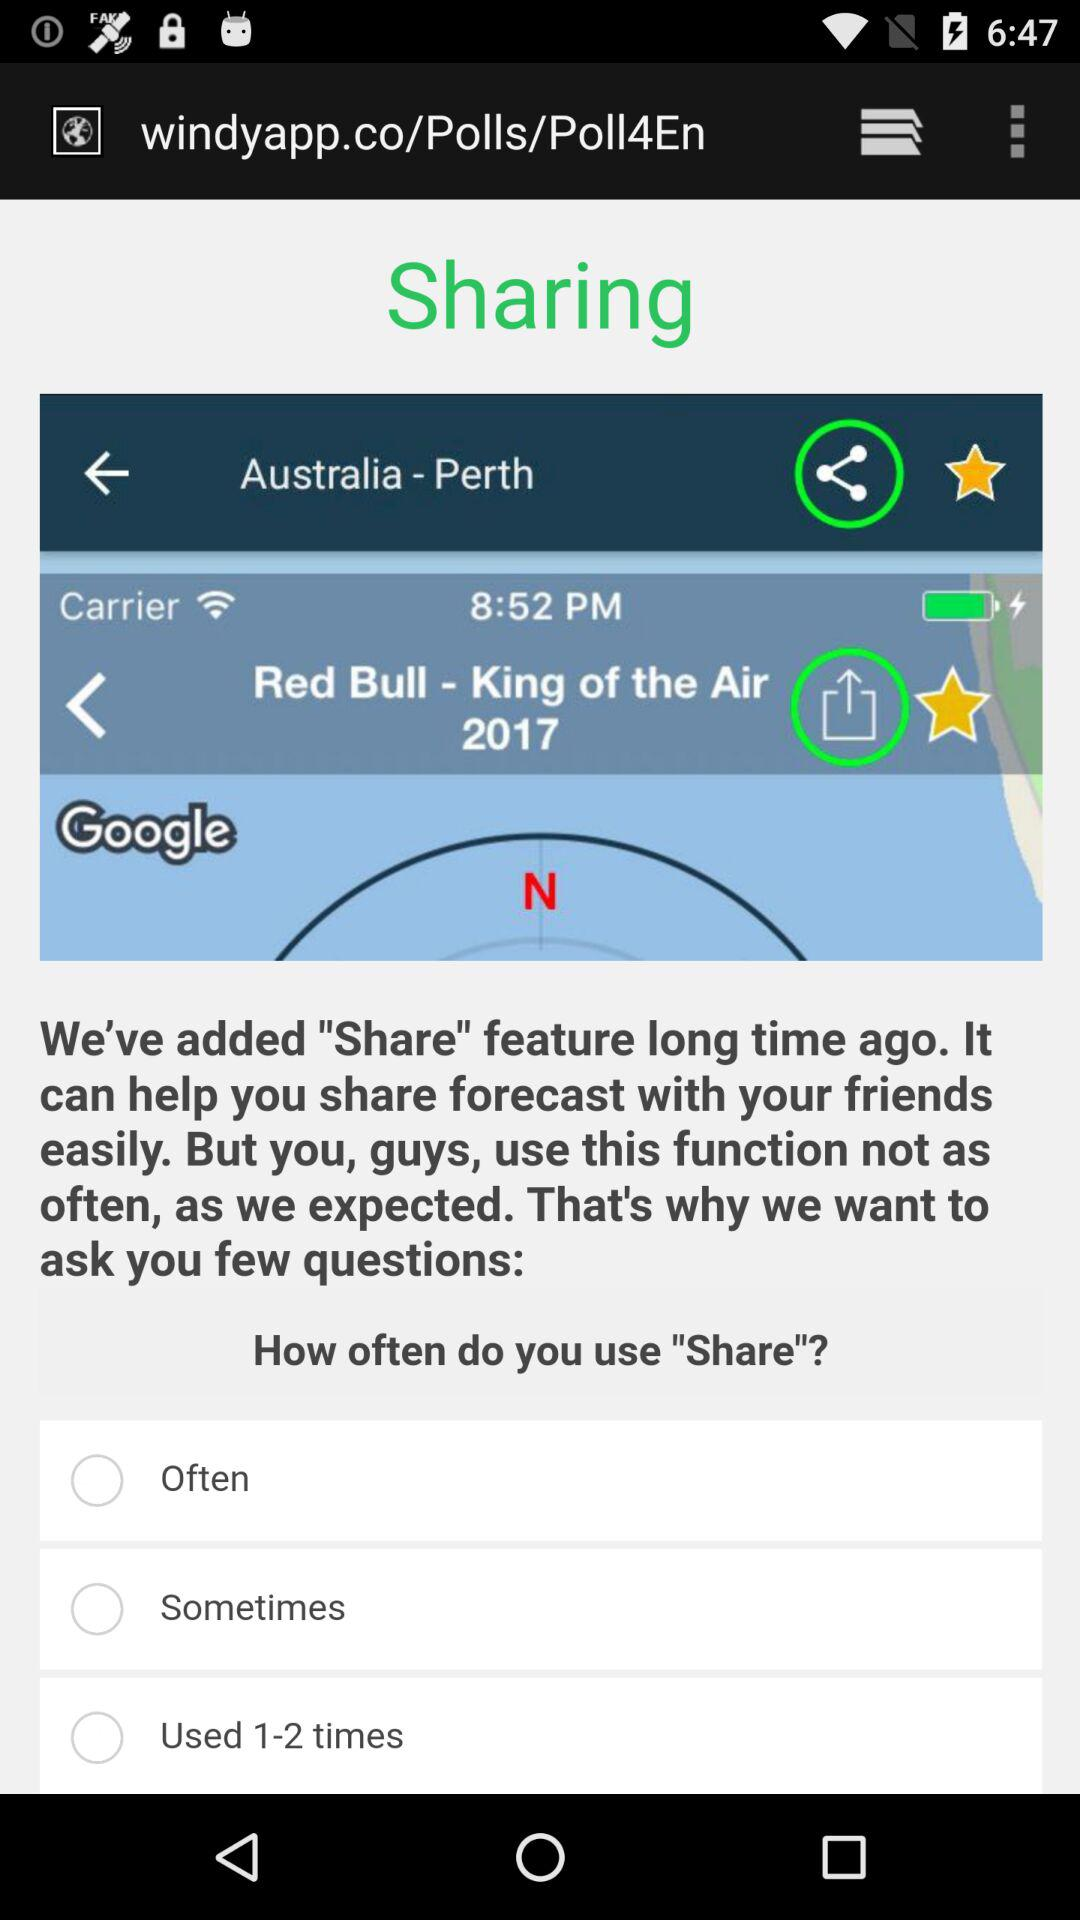How many 'Share' options are there?
Answer the question using a single word or phrase. 3 